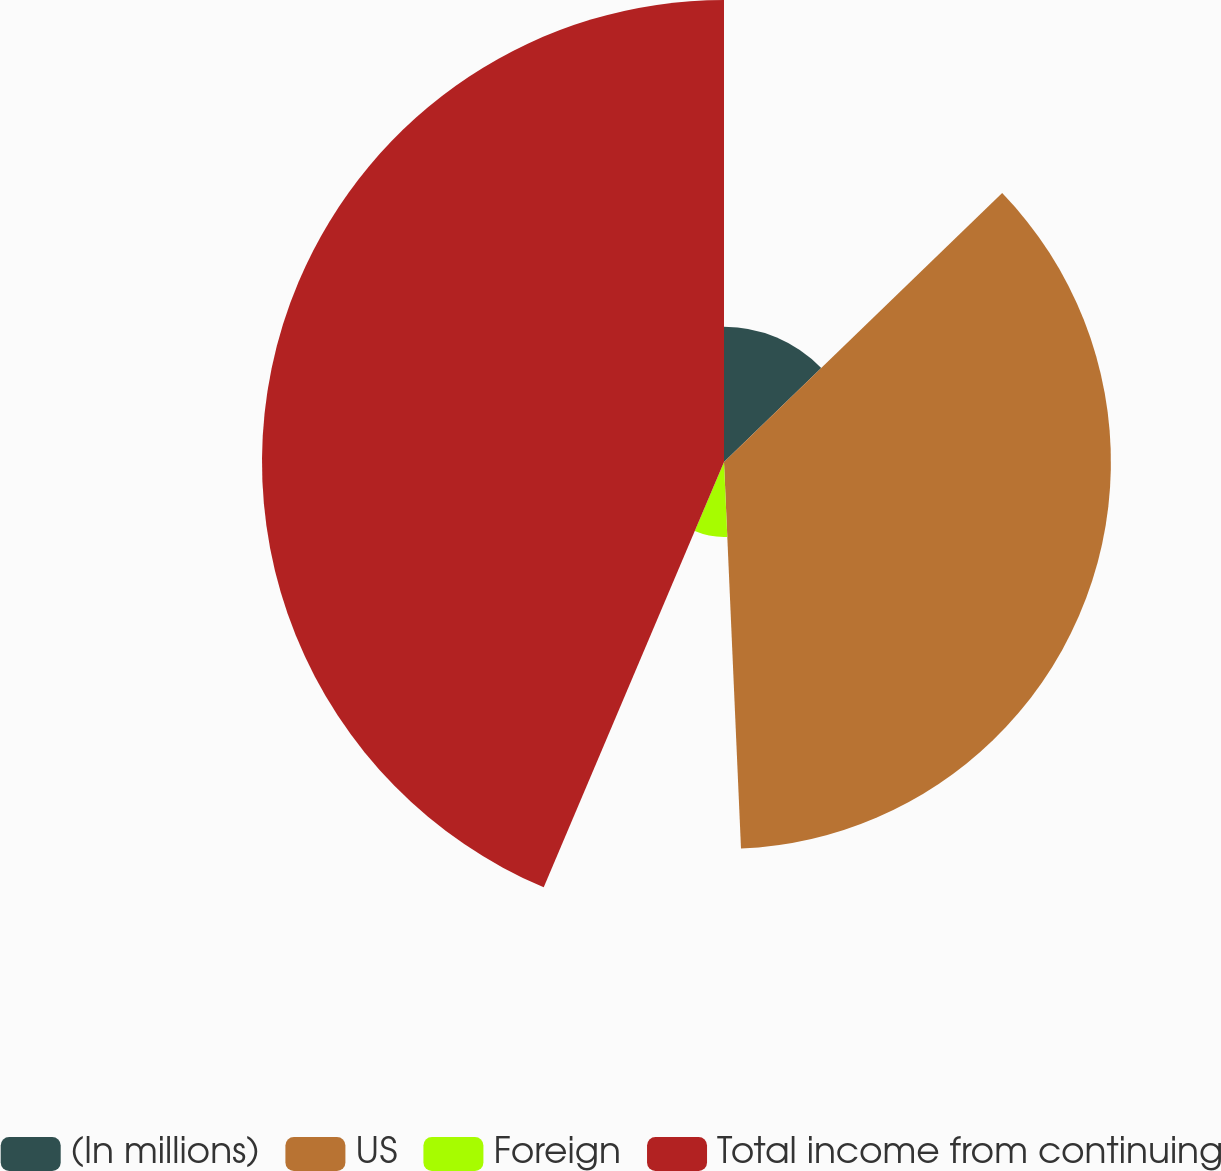<chart> <loc_0><loc_0><loc_500><loc_500><pie_chart><fcel>(In millions)<fcel>US<fcel>Foreign<fcel>Total income from continuing<nl><fcel>12.77%<fcel>36.53%<fcel>7.08%<fcel>43.62%<nl></chart> 